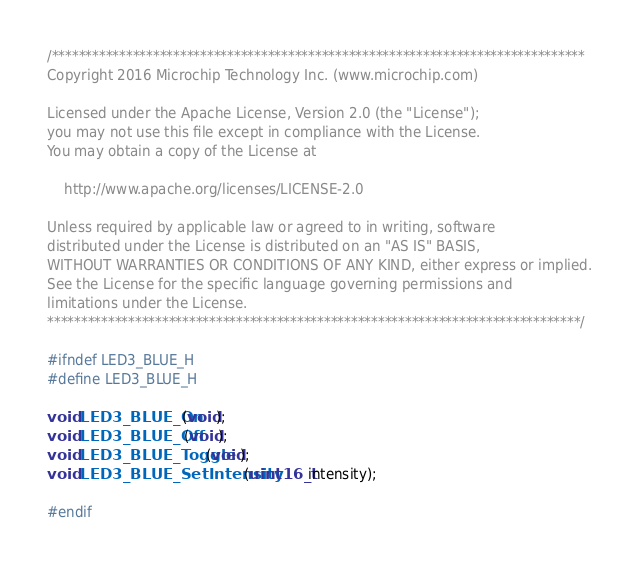Convert code to text. <code><loc_0><loc_0><loc_500><loc_500><_C_>/*******************************************************************************
Copyright 2016 Microchip Technology Inc. (www.microchip.com)

Licensed under the Apache License, Version 2.0 (the "License");
you may not use this file except in compliance with the License.
You may obtain a copy of the License at

    http://www.apache.org/licenses/LICENSE-2.0

Unless required by applicable law or agreed to in writing, software
distributed under the License is distributed on an "AS IS" BASIS,
WITHOUT WARRANTIES OR CONDITIONS OF ANY KIND, either express or implied.
See the License for the specific language governing permissions and
limitations under the License.
*******************************************************************************/

#ifndef LED3_BLUE_H
#define LED3_BLUE_H

void LED3_BLUE_On(void);
void LED3_BLUE_Off(void);
void LED3_BLUE_Toggle(void);
void LED3_BLUE_SetIntensity(uint16_t intensity);

#endif
</code> 